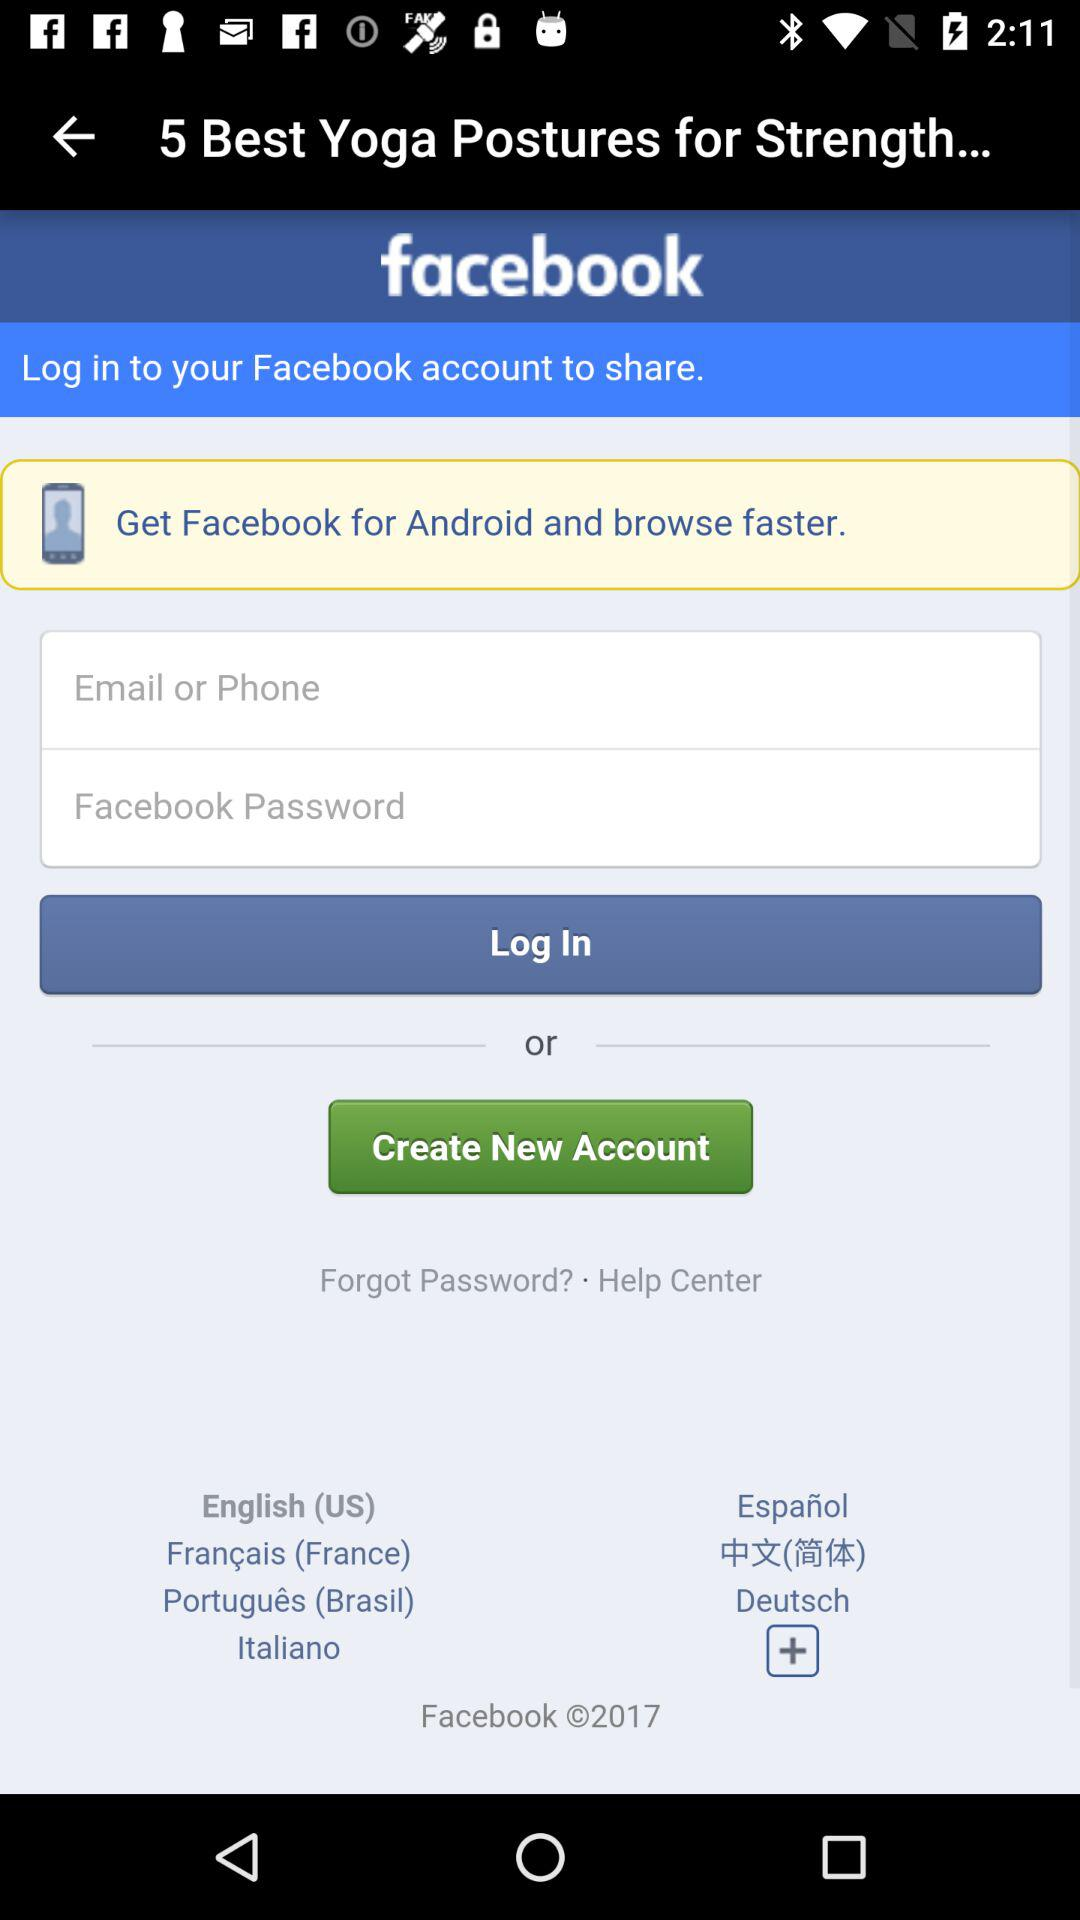How many text inputs are required to login?
Answer the question using a single word or phrase. 2 